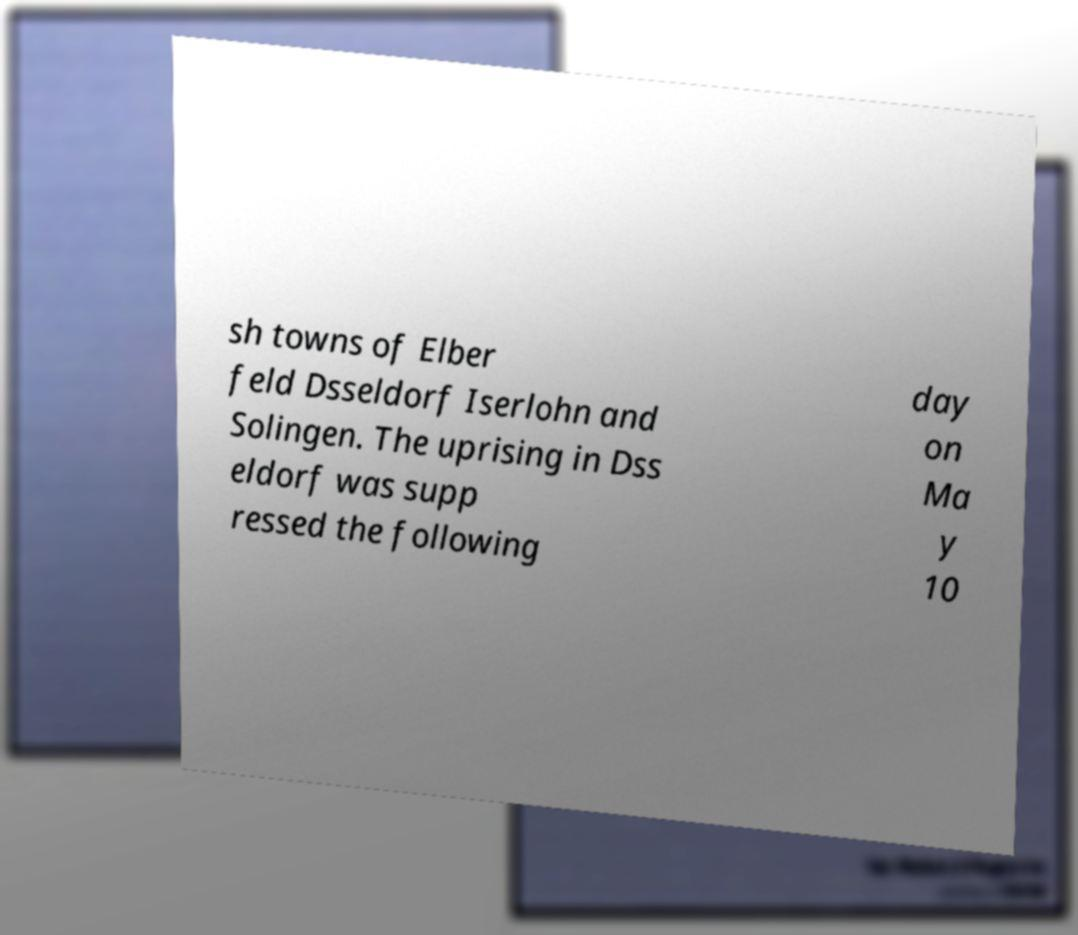Can you read and provide the text displayed in the image?This photo seems to have some interesting text. Can you extract and type it out for me? sh towns of Elber feld Dsseldorf Iserlohn and Solingen. The uprising in Dss eldorf was supp ressed the following day on Ma y 10 